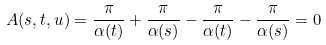Convert formula to latex. <formula><loc_0><loc_0><loc_500><loc_500>A ( s , t , u ) = \frac { \pi } { \alpha ( t ) } + \frac { \pi } { \alpha ( s ) } - \frac { \pi } { \alpha ( t ) } - \frac { \pi } { \alpha ( s ) } = 0</formula> 